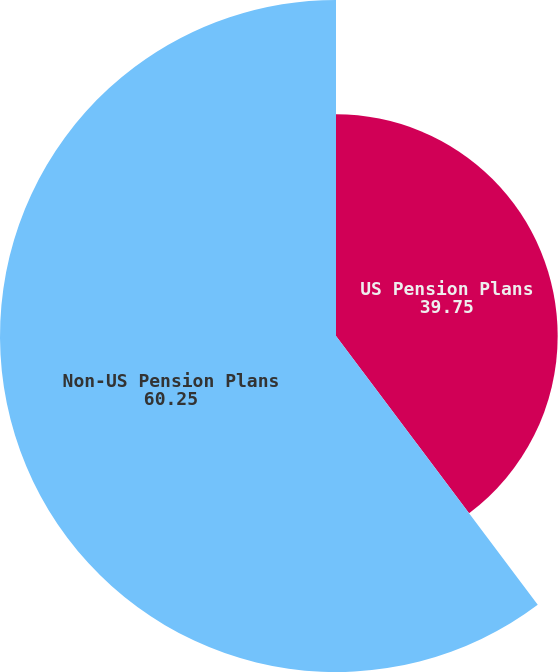Convert chart to OTSL. <chart><loc_0><loc_0><loc_500><loc_500><pie_chart><fcel>US Pension Plans<fcel>Non-US Pension Plans<nl><fcel>39.75%<fcel>60.25%<nl></chart> 